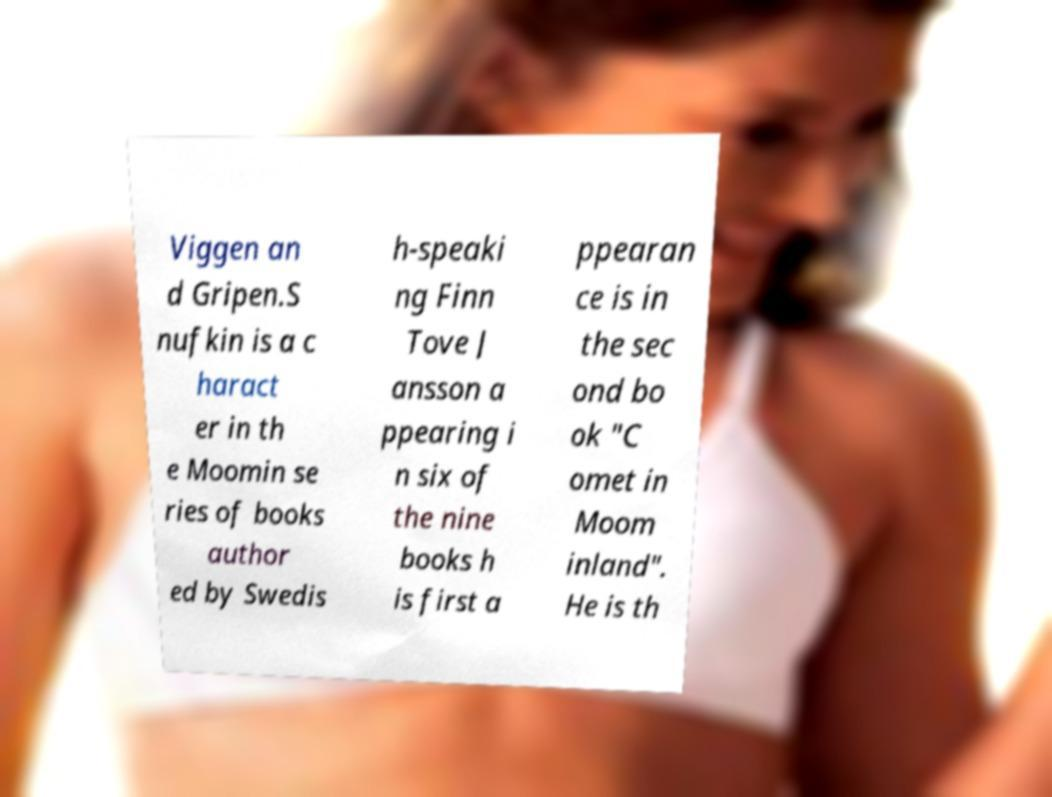Could you assist in decoding the text presented in this image and type it out clearly? Viggen an d Gripen.S nufkin is a c haract er in th e Moomin se ries of books author ed by Swedis h-speaki ng Finn Tove J ansson a ppearing i n six of the nine books h is first a ppearan ce is in the sec ond bo ok "C omet in Moom inland". He is th 